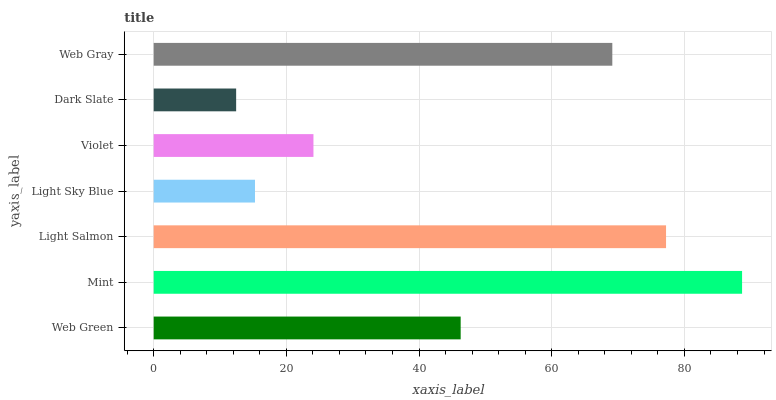Is Dark Slate the minimum?
Answer yes or no. Yes. Is Mint the maximum?
Answer yes or no. Yes. Is Light Salmon the minimum?
Answer yes or no. No. Is Light Salmon the maximum?
Answer yes or no. No. Is Mint greater than Light Salmon?
Answer yes or no. Yes. Is Light Salmon less than Mint?
Answer yes or no. Yes. Is Light Salmon greater than Mint?
Answer yes or no. No. Is Mint less than Light Salmon?
Answer yes or no. No. Is Web Green the high median?
Answer yes or no. Yes. Is Web Green the low median?
Answer yes or no. Yes. Is Mint the high median?
Answer yes or no. No. Is Mint the low median?
Answer yes or no. No. 